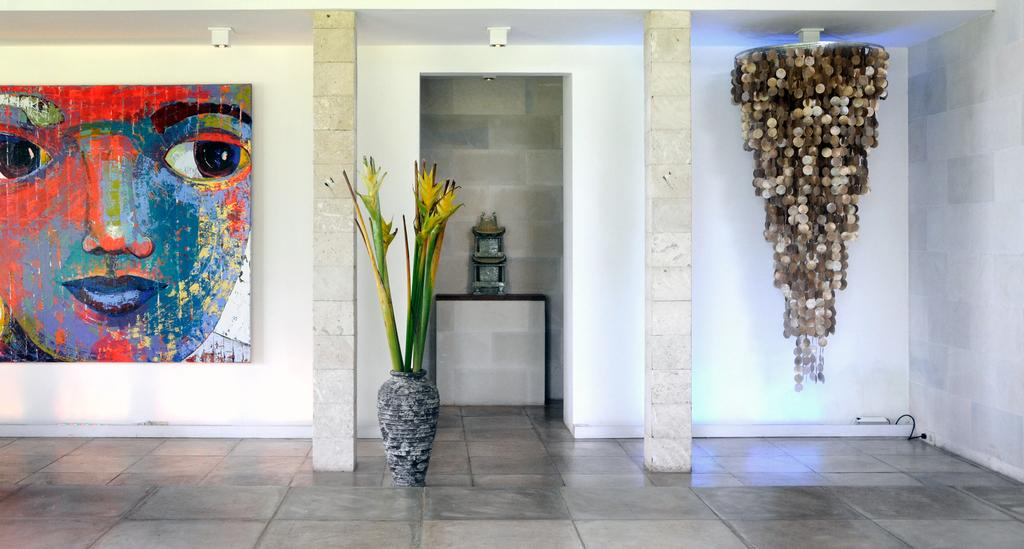What type of setting is shown in the image? The image depicts an inside view of a room. What can be seen in the room? There is a flower vase, a chandelier light, and a painting on the wall in the room. How many bikes are hanging from the wire in the room? There are no bikes or wires present in the image. What color is the pocket on the wall in the room? There is no pocket present on the wall in the image. 